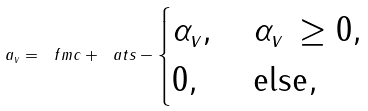Convert formula to latex. <formula><loc_0><loc_0><loc_500><loc_500>\, a _ { v } = \ f m c + \ a t s - \begin{cases} \alpha _ { v } , & \, \alpha _ { v } \, \geq 0 , \\ 0 , & \, \text {else} , \end{cases}</formula> 